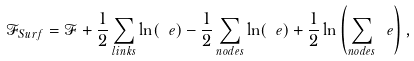Convert formula to latex. <formula><loc_0><loc_0><loc_500><loc_500>\mathcal { F } _ { S u r f } = \mathcal { F } + \frac { 1 } { 2 } \sum _ { l i n k s } \ln ( \ e ) - \frac { 1 } { 2 } \sum _ { n o d e s } \ln ( \ e ) + \frac { 1 } { 2 } \ln \left ( \sum _ { n o d e s } \ e \right ) ,</formula> 